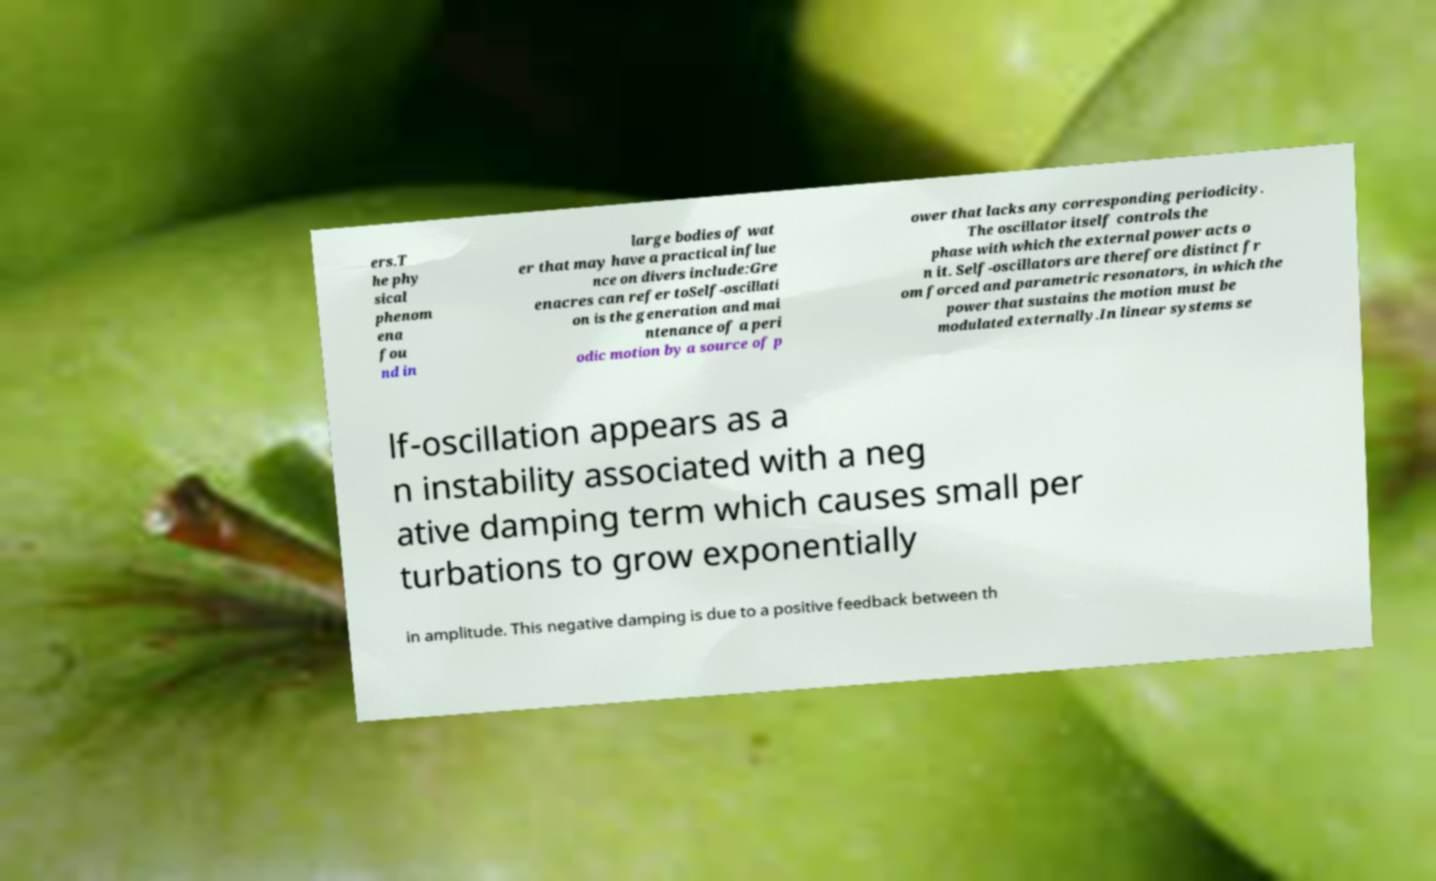Could you extract and type out the text from this image? ers.T he phy sical phenom ena fou nd in large bodies of wat er that may have a practical influe nce on divers include:Gre enacres can refer toSelf-oscillati on is the generation and mai ntenance of a peri odic motion by a source of p ower that lacks any corresponding periodicity. The oscillator itself controls the phase with which the external power acts o n it. Self-oscillators are therefore distinct fr om forced and parametric resonators, in which the power that sustains the motion must be modulated externally.In linear systems se lf-oscillation appears as a n instability associated with a neg ative damping term which causes small per turbations to grow exponentially in amplitude. This negative damping is due to a positive feedback between th 